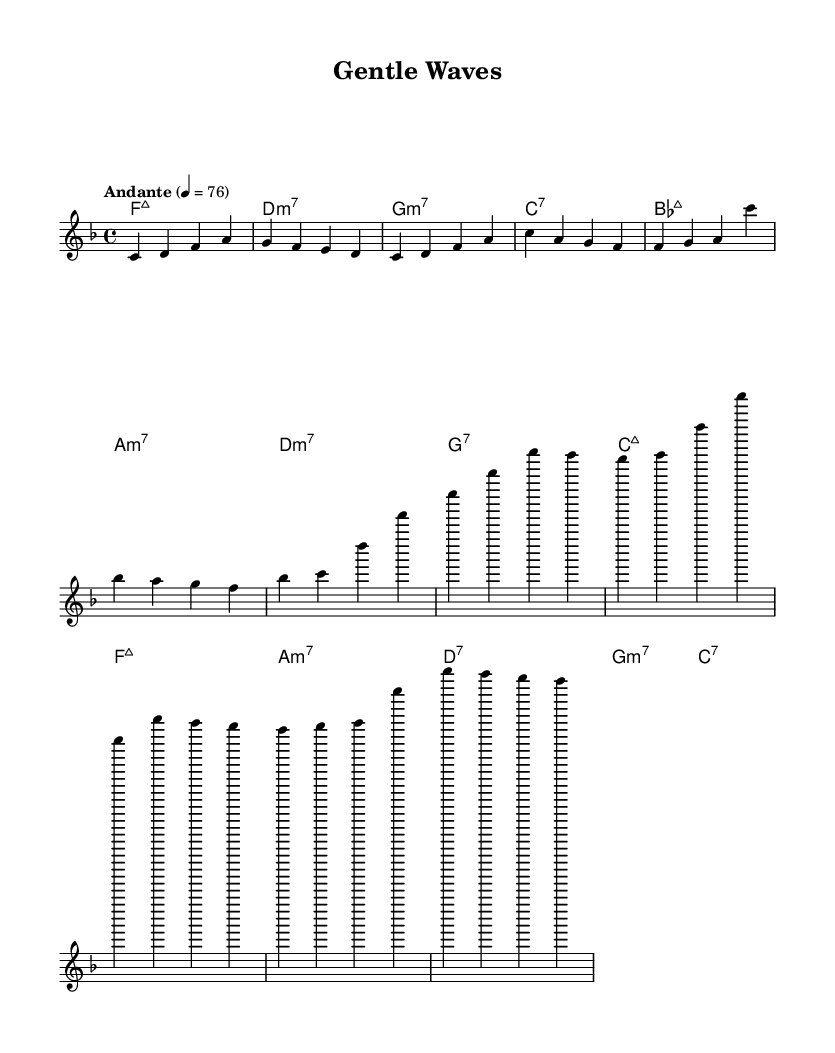What is the key signature of this music? The key signature is F major, which has one flat (B flat). This can be identified in the beginning of the score where the key signature is notated.
Answer: F major What is the time signature of this music? The time signature is 4/4, which means there are four beats in a measure and the quarter note gets one beat. This is indicated at the beginning of the music.
Answer: 4/4 What is the tempo marking for this piece? The tempo marking is "Andante" with a metronome marking of 76, indicating a moderately slow tempo. This can be found at the start of the score near the time signature.
Answer: Andante, 76 How many measures are in the verse section? The verse section consists of two measures as indicated by the notation shown for 'Verse'. Each measure contains four beats, leading to the conclusion that there are two complete measures of music here.
Answer: 2 What type of seventh chord appears most frequently in the harmonies? The most frequently occurring seventh chord in the harmonies is the minor seventh chord, specifically D minor 7, G minor 7, and A minor 7 in the score. The chord changes noted reveal this repetition.
Answer: Minor seventh What is the chord progression for the chorus? The chord progression for the chorus is B flat major 7, A minor 7, D minor 7, G major 7, C major 7, and F major 7. This can be deduced by examining the sequence of chords written under the chorus section.
Answer: B flat major 7, A minor 7, D minor 7, G major 7, C major 7, F major 7 What type of music fusion does this sheet represent? This sheet represents a smooth bossa nova-pop blend, characterized by its relaxed rhythms and melodic lines typical of the bossa nova genre combined with pop elements. This is evident from the overall style and structure of the piece.
Answer: Smooth bossa nova-pop blend 